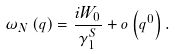Convert formula to latex. <formula><loc_0><loc_0><loc_500><loc_500>\omega _ { N } \left ( q \right ) = \frac { i W _ { 0 } } { \gamma ^ { S } _ { 1 } } + o \left ( q ^ { 0 } \right ) .</formula> 